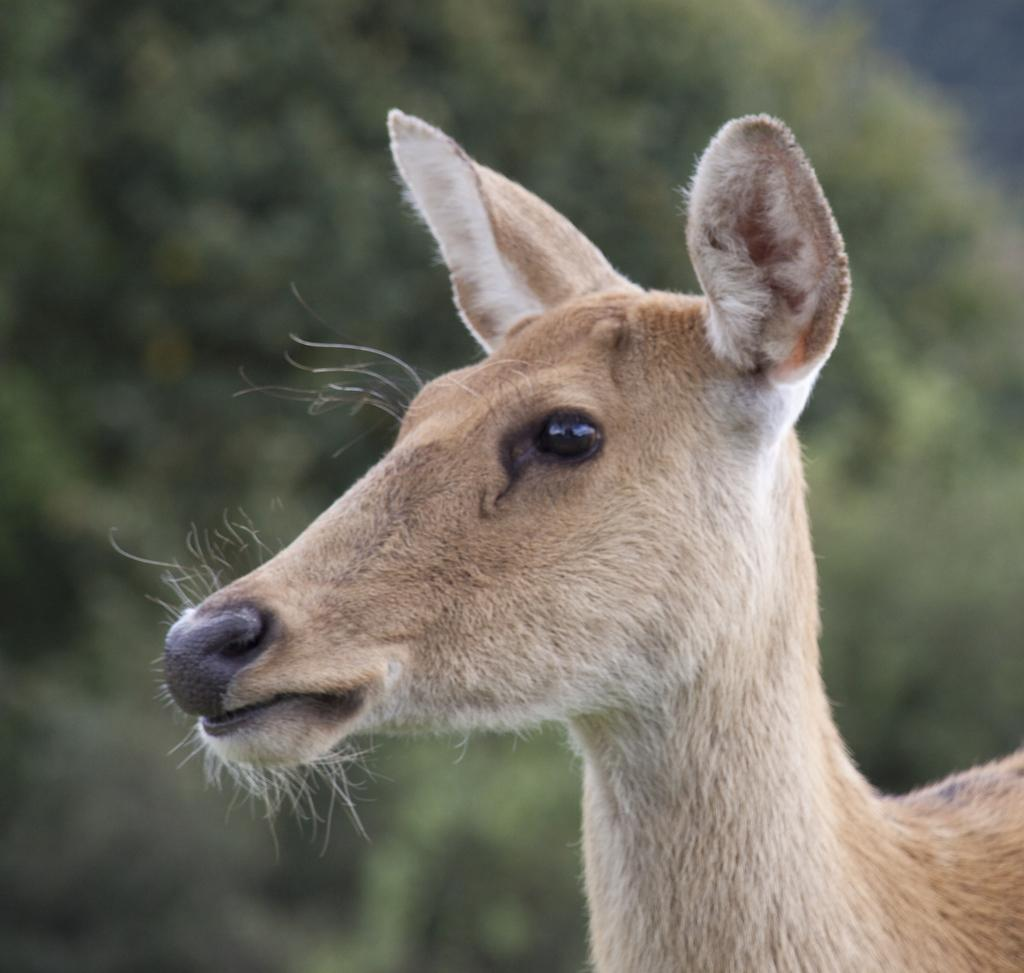What animal is present in the image? There is a deer in the image. Can you describe the background of the image? The background of the image is blurred. Is there a train visible in the image? No, there is no train present in the image. How does the deer maintain its balance in the image? The deer's balance is not mentioned or visible in the image, as it is a still image. 